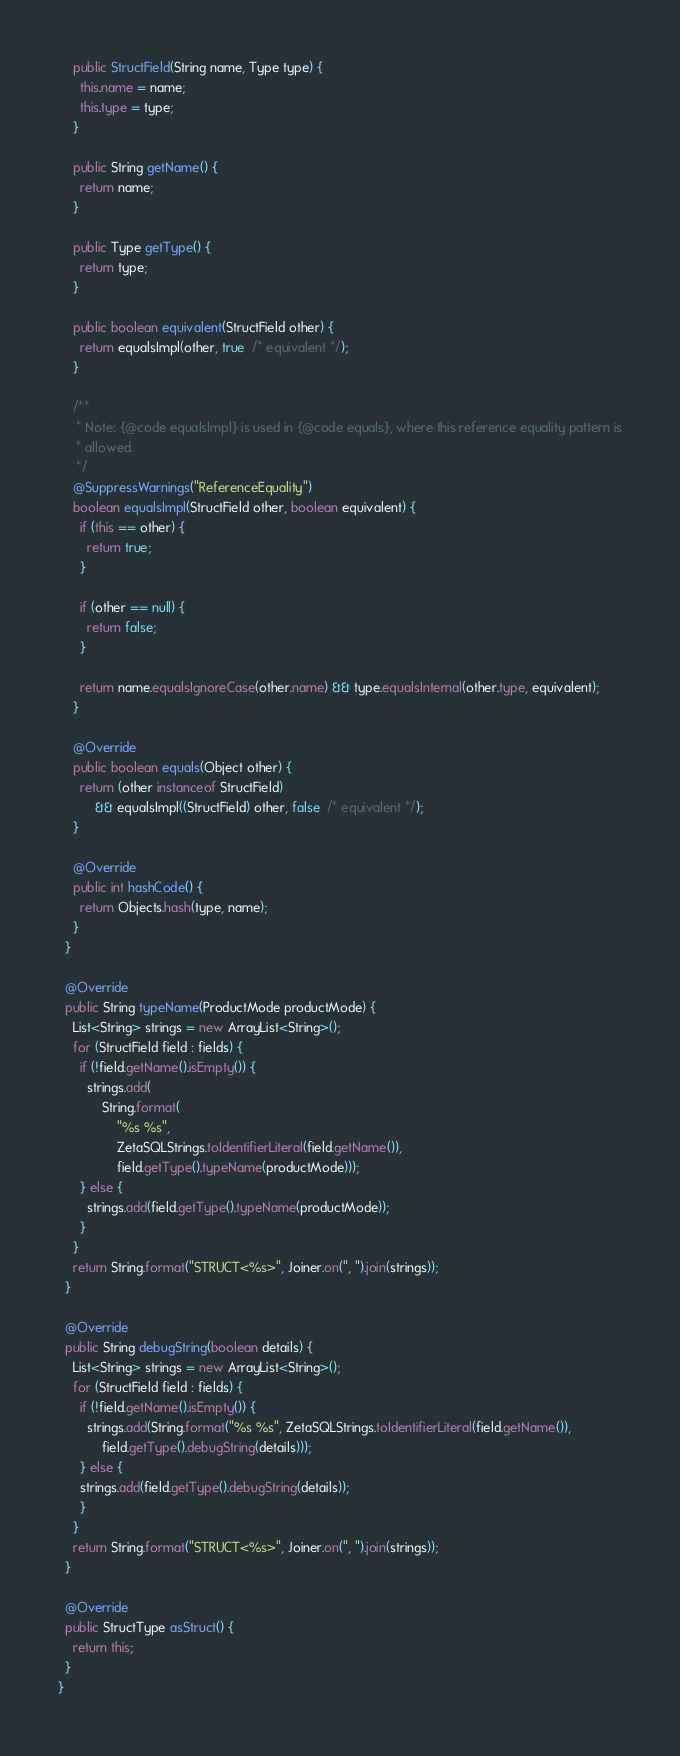<code> <loc_0><loc_0><loc_500><loc_500><_Java_>
    public StructField(String name, Type type) {
      this.name = name;
      this.type = type;
    }

    public String getName() {
      return name;
    }

    public Type getType() {
      return type;
    }

    public boolean equivalent(StructField other) {
      return equalsImpl(other, true  /* equivalent */);
    }

    /**
     * Note: {@code equalsImpl} is used in {@code equals}, where this reference equality pattern is
     * allowed.
     */
    @SuppressWarnings("ReferenceEquality")
    boolean equalsImpl(StructField other, boolean equivalent) {
      if (this == other) {
        return true;
      }

      if (other == null) {
        return false;
      }

      return name.equalsIgnoreCase(other.name) && type.equalsInternal(other.type, equivalent);
    }

    @Override
    public boolean equals(Object other) {
      return (other instanceof StructField)
          && equalsImpl((StructField) other, false  /* equivalent */);
    }

    @Override
    public int hashCode() {
      return Objects.hash(type, name);
    }
  }

  @Override
  public String typeName(ProductMode productMode) {
    List<String> strings = new ArrayList<String>();
    for (StructField field : fields) {
      if (!field.getName().isEmpty()) {
        strings.add(
            String.format(
                "%s %s",
                ZetaSQLStrings.toIdentifierLiteral(field.getName()),
                field.getType().typeName(productMode)));
      } else {
        strings.add(field.getType().typeName(productMode));
      }
    }
    return String.format("STRUCT<%s>", Joiner.on(", ").join(strings));
  }

  @Override
  public String debugString(boolean details) {
    List<String> strings = new ArrayList<String>();
    for (StructField field : fields) {
      if (!field.getName().isEmpty()) {
        strings.add(String.format("%s %s", ZetaSQLStrings.toIdentifierLiteral(field.getName()),
            field.getType().debugString(details)));
      } else {
      strings.add(field.getType().debugString(details));
      }
    }
    return String.format("STRUCT<%s>", Joiner.on(", ").join(strings));
  }

  @Override
  public StructType asStruct() {
    return this;
  }
}
</code> 